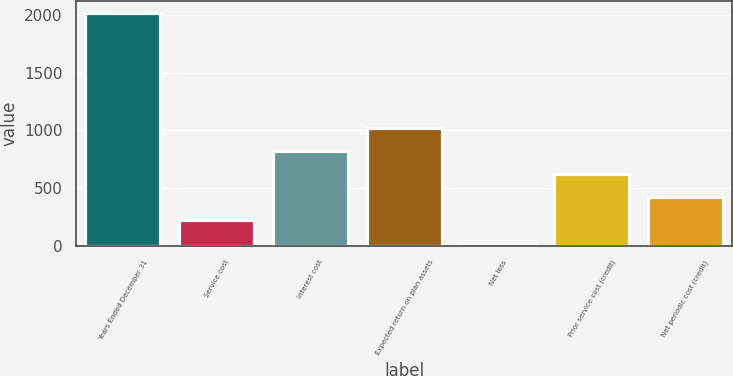<chart> <loc_0><loc_0><loc_500><loc_500><bar_chart><fcel>Years Ended December 31<fcel>Service cost<fcel>Interest cost<fcel>Expected return on plan assets<fcel>Net loss<fcel>Prior service cost (credit)<fcel>Net periodic cost (credit)<nl><fcel>2015<fcel>220.4<fcel>818.6<fcel>1018<fcel>21<fcel>619.2<fcel>419.8<nl></chart> 